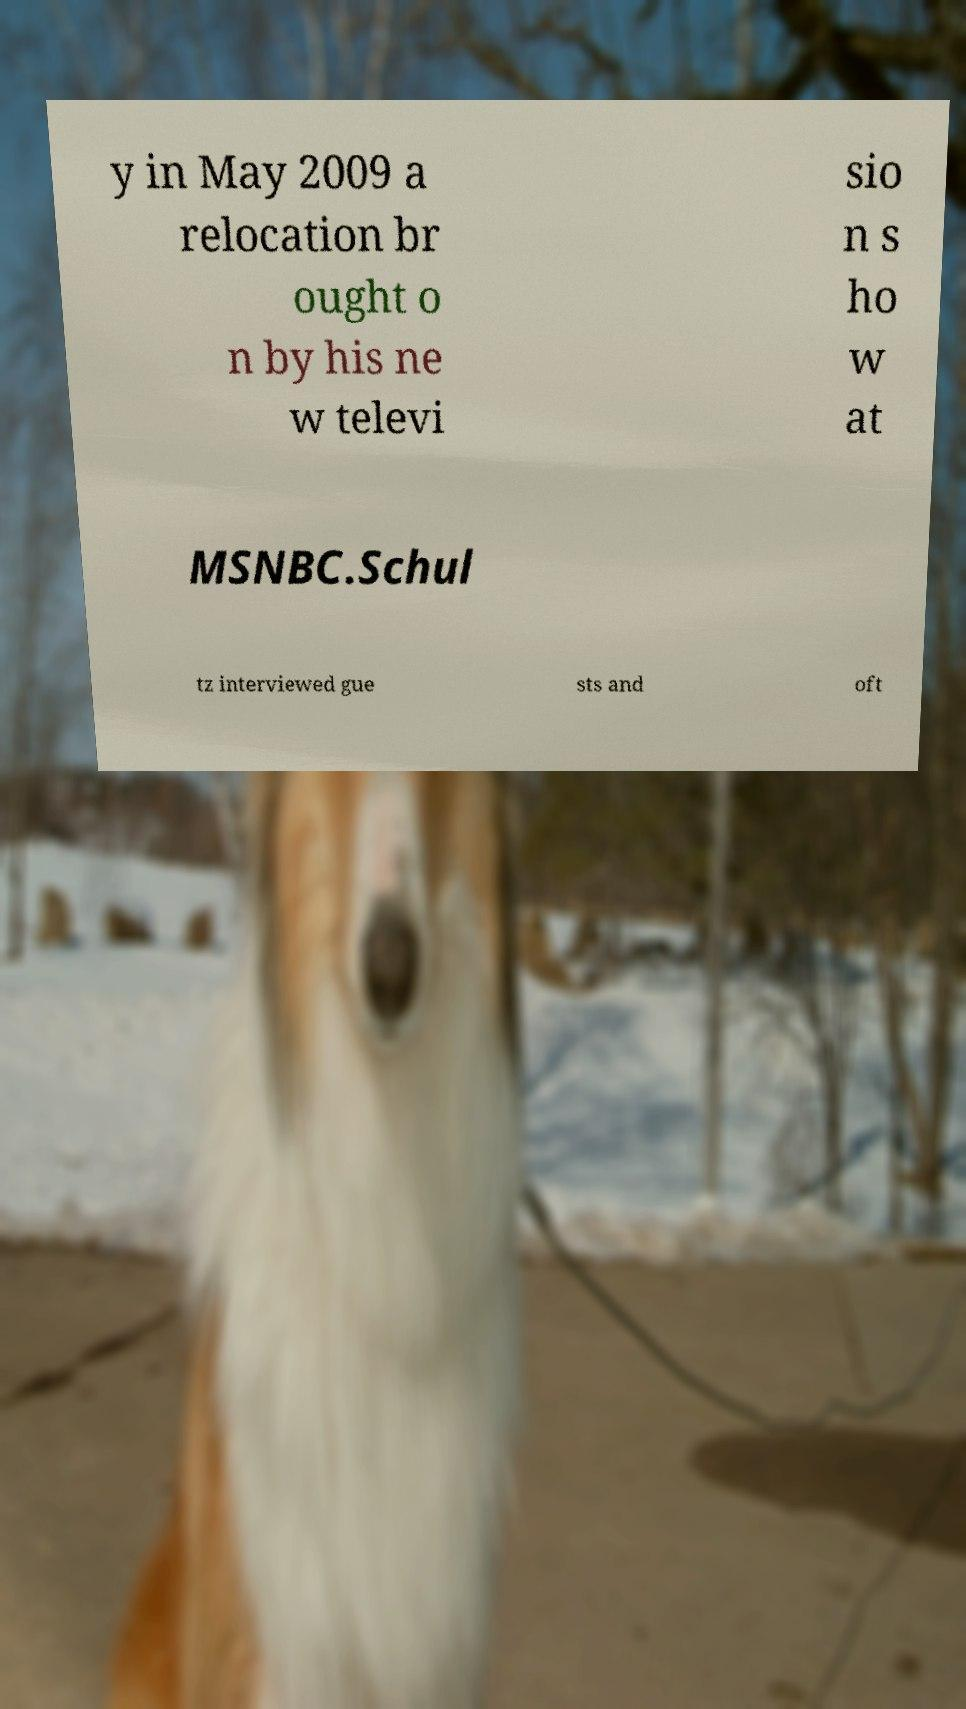Can you read and provide the text displayed in the image?This photo seems to have some interesting text. Can you extract and type it out for me? y in May 2009 a relocation br ought o n by his ne w televi sio n s ho w at MSNBC.Schul tz interviewed gue sts and oft 